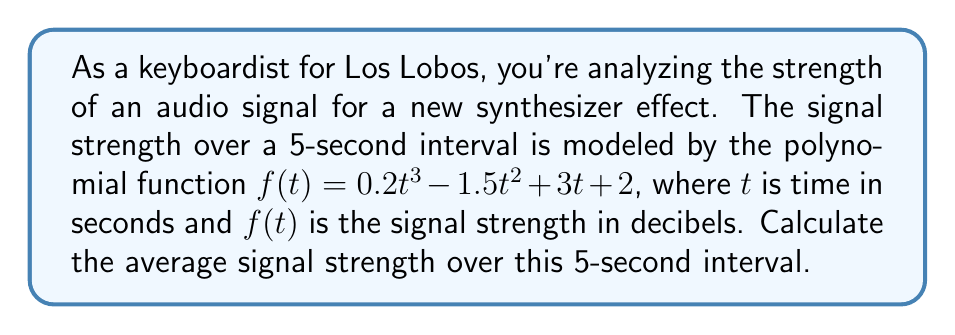What is the answer to this math problem? To find the average signal strength, we need to:

1. Calculate the area under the curve from $t=0$ to $t=5$.
2. Divide this area by the time interval (5 seconds).

Step 1: Calculate the area under the curve
The area under the curve is given by the definite integral:

$$\int_0^5 (0.2t^3 - 1.5t^2 + 3t + 2) dt$$

Let's integrate term by term:

$$\begin{align*}
\int_0^5 0.2t^3 dt &= 0.2 \cdot \frac{t^4}{4} \Big|_0^5 = 0.2 \cdot \frac{625}{4} - 0 = 31.25 \\
\int_0^5 -1.5t^2 dt &= -1.5 \cdot \frac{t^3}{3} \Big|_0^5 = -1.5 \cdot \frac{125}{3} - 0 = -62.5 \\
\int_0^5 3t dt &= 3 \cdot \frac{t^2}{2} \Big|_0^5 = 3 \cdot \frac{25}{2} - 0 = 37.5 \\
\int_0^5 2 dt &= 2t \Big|_0^5 = 10 - 0 = 10
\end{align*}$$

Sum these results: $31.25 - 62.5 + 37.5 + 10 = 16.25$

Step 2: Divide by the time interval
Average signal strength = $\frac{16.25}{5} = 3.25$ decibels
Answer: 3.25 dB 